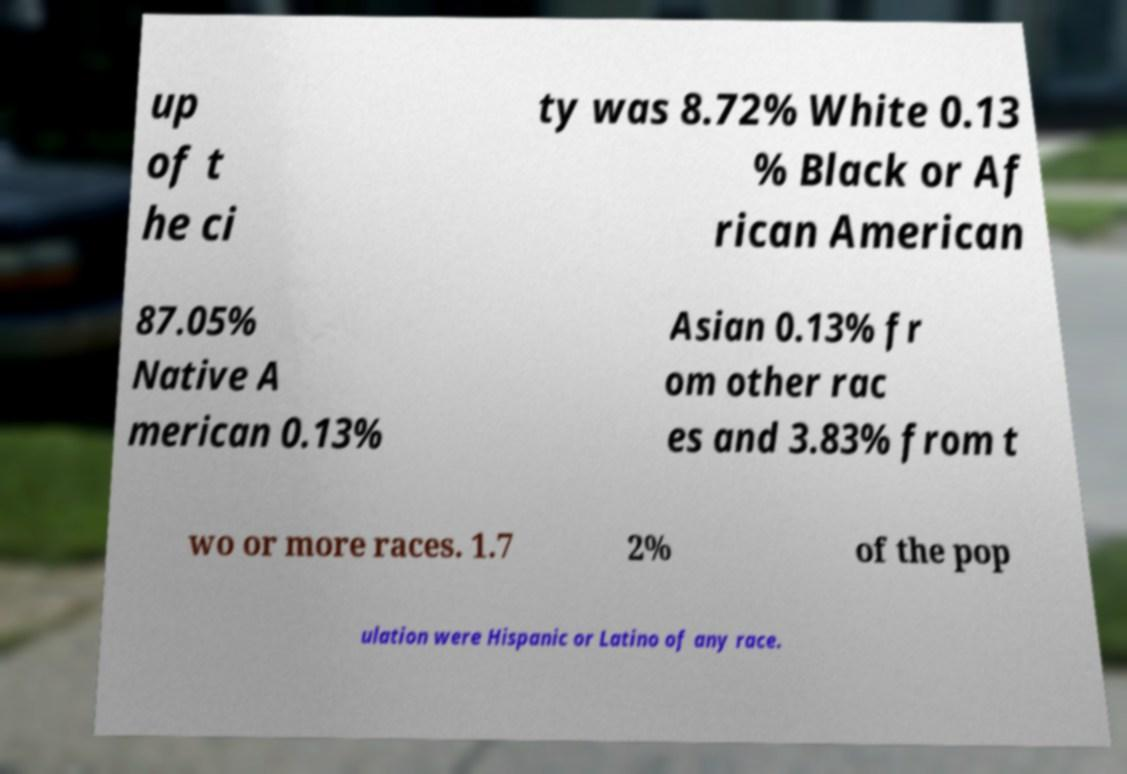I need the written content from this picture converted into text. Can you do that? up of t he ci ty was 8.72% White 0.13 % Black or Af rican American 87.05% Native A merican 0.13% Asian 0.13% fr om other rac es and 3.83% from t wo or more races. 1.7 2% of the pop ulation were Hispanic or Latino of any race. 